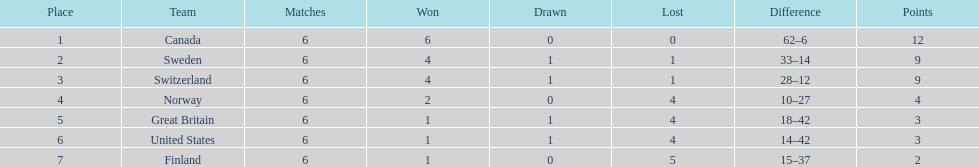What team ranked following sweden? Switzerland. 